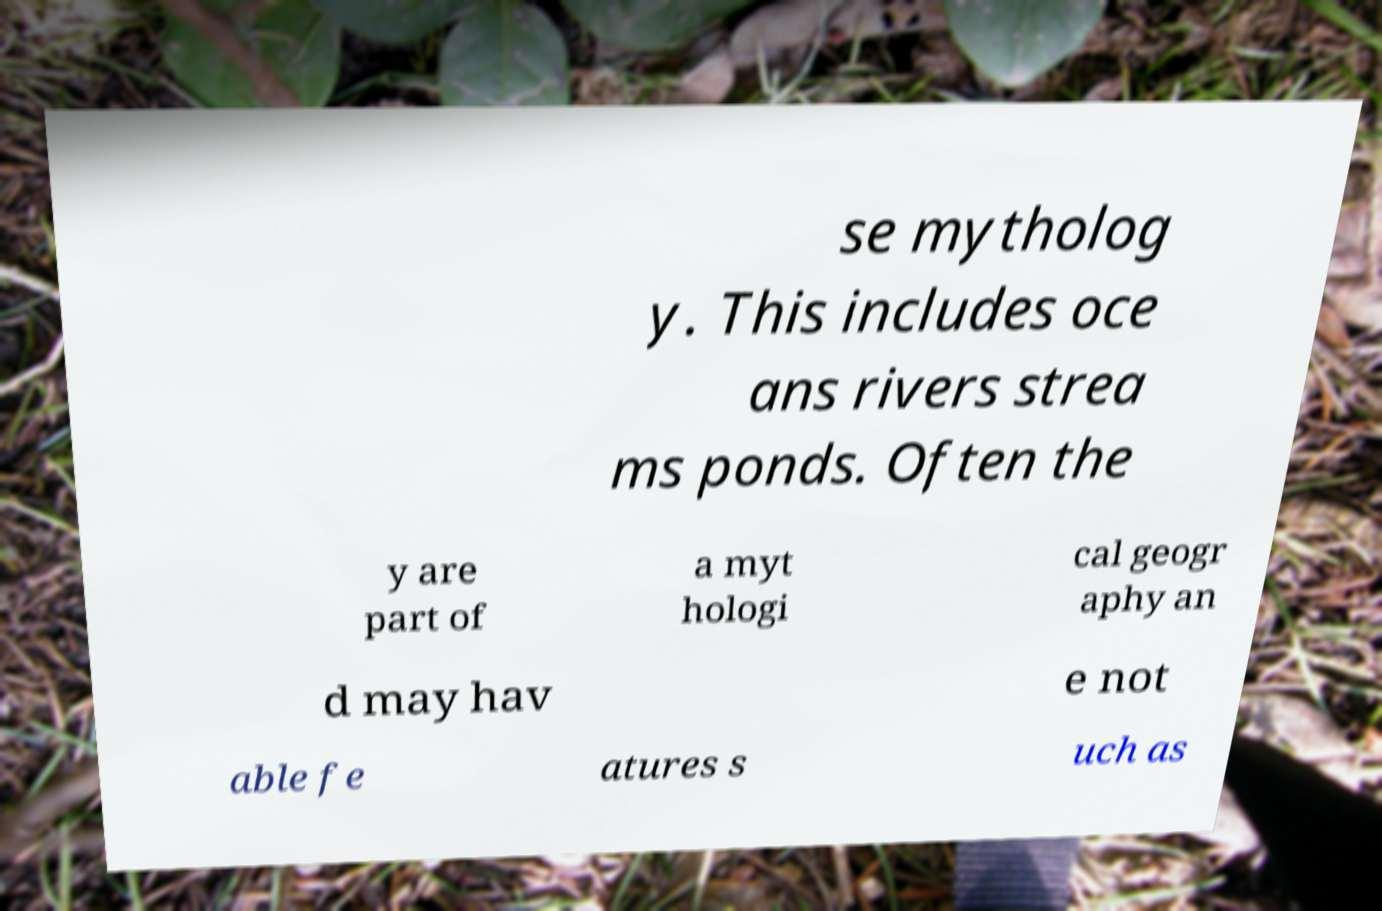Can you accurately transcribe the text from the provided image for me? se mytholog y. This includes oce ans rivers strea ms ponds. Often the y are part of a myt hologi cal geogr aphy an d may hav e not able fe atures s uch as 